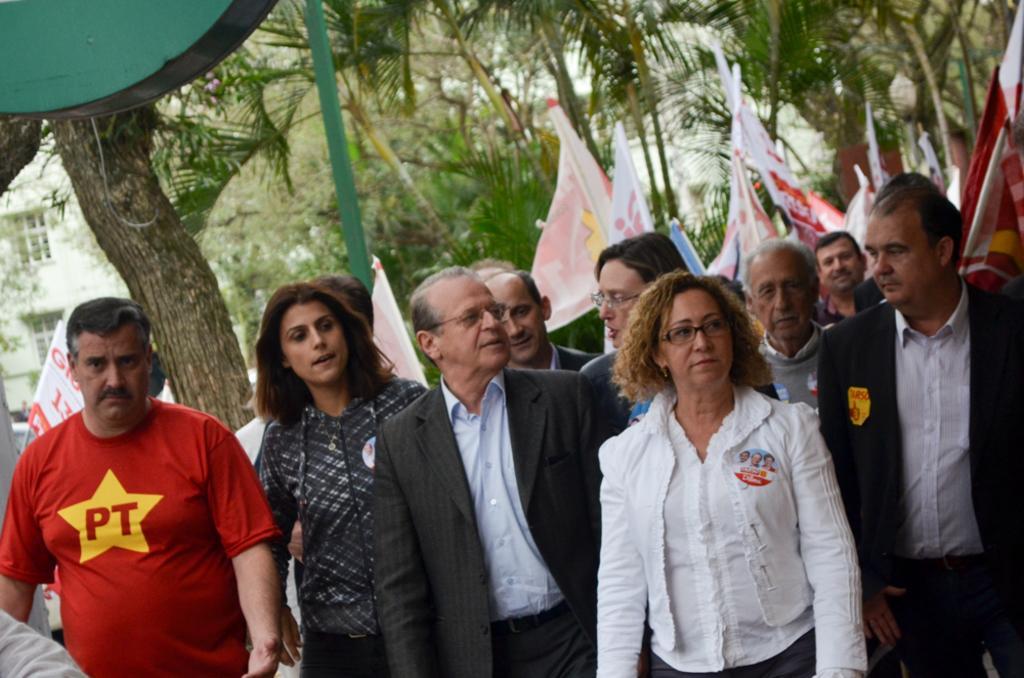How would you summarize this image in a sentence or two? In this image, I can see a group of people standing. These look like the flags. In the background, I can see the trees. I can see a pole. On the left side of the image, that looks like a building and a tree trunk. 